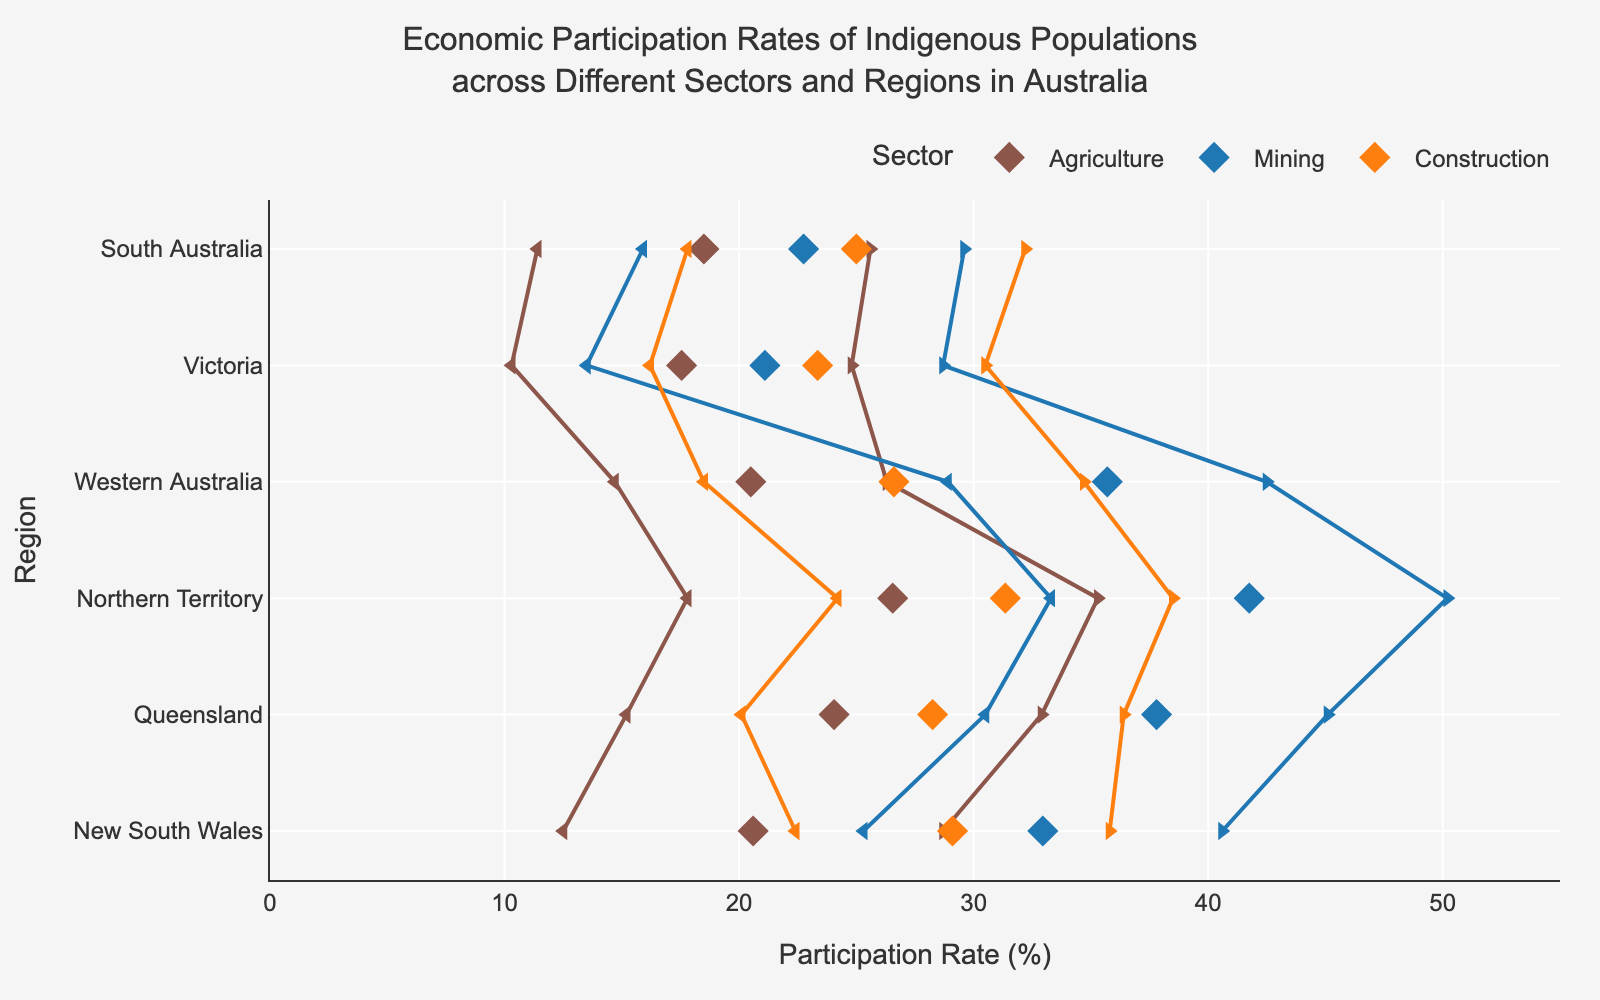what is the title of the figure? The title is located at the top-center of the plot and provides a summary of what the entire plot is about. It reads "Economic Participation Rates of Indigenous Populations across Different Sectors and Regions in Australia".
Answer: Economic Participation Rates of Indigenous Populations across Different Sectors and Regions in Australia Which sector in the Northern Territory has the highest maximum participation rate? By examining the range of each sector in the Northern Territory, Mining has the highest maximum participation rate at 50.2%.
Answer: Mining Which region has the lowest minimum participation rate in the Agriculture sector? Comparing the minimum participation rates of the Agriculture sector across all regions, Victoria has the lowest at 10.3%.
Answer: Victoria What is the average participation rate for the Construction sector in Queensland? The average can be calculated by taking the sum of the minimum and maximum participation rates and dividing by 2: (20.1 + 36.4)/2 = 28.25%.
Answer: 28.25% Is the participation rate range in the Mining sector wider in New South Wales or Western Australia? To determine the wider range, we need to subtract the minimum rate from the maximum rate in each region. For New South Wales: 40.6 - 25.3 = 15.3%. For Western Australia: 42.5 - 28.9 = 13.6%. So, New South Wales has a wider range.
Answer: New South Wales How does the minimum participation rate in the Agriculture sector in New South Wales compare to that in Queensland? By examining the plot, the minimum participation rate in Agriculture for New South Wales is 12.5%, while in Queensland, it is 15.2%. Therefore, New South Wales has a lower minimum participation rate.
Answer: Lower What is the difference between the maximum participation rates in the Mining sector in Queensland and Victoria? Subtracting the maximum rate in Victoria (28.7%) from the maximum rate in Queensland (45.1%) gives: 45.1 - 28.7 = 16.4%.
Answer: 16.4% Which region has the narrowest participation range in the Construction sector? We calculate the range for each region in the Construction sector by subtracting the minimum participation rate from the maximum. For New South Wales: 35.8 - 22.4 = 13.4%. For Queensland: 36.4 - 20.1 = 16.3%. For Northern Territory: 38.5 - 24.2 = 14.3%. For Western Australia: 34.7 - 18.5 = 16.2%. For Victoria: 30.5 - 16.2 = 14.3%. For South Australia: 32.2 - 17.8 = 14.4%. New South Wales has the narrowest range at 13.4%.
Answer: New South Wales 